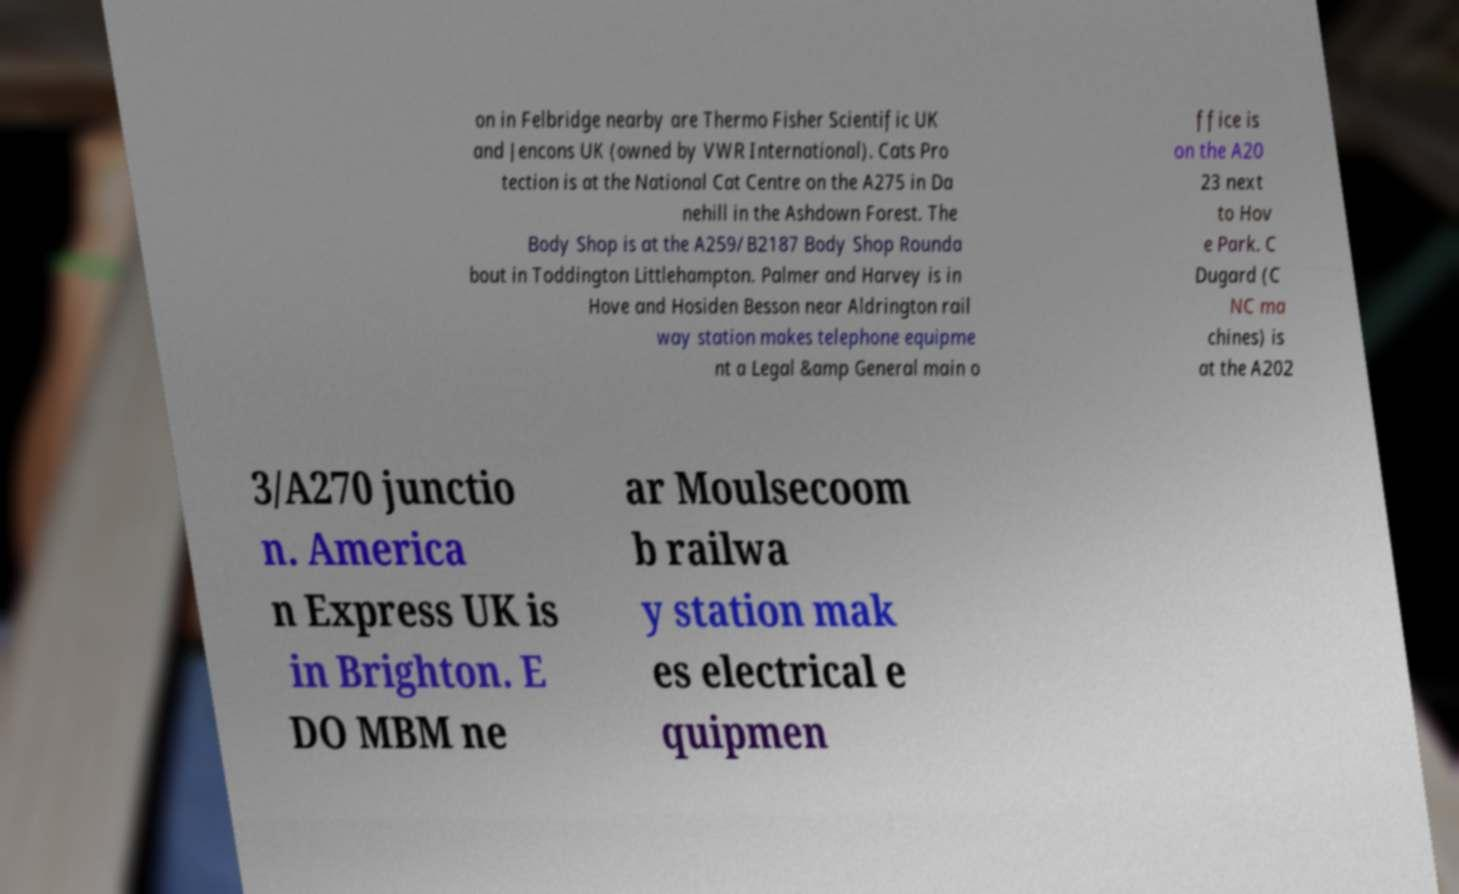Can you accurately transcribe the text from the provided image for me? on in Felbridge nearby are Thermo Fisher Scientific UK and Jencons UK (owned by VWR International). Cats Pro tection is at the National Cat Centre on the A275 in Da nehill in the Ashdown Forest. The Body Shop is at the A259/B2187 Body Shop Rounda bout in Toddington Littlehampton. Palmer and Harvey is in Hove and Hosiden Besson near Aldrington rail way station makes telephone equipme nt a Legal &amp General main o ffice is on the A20 23 next to Hov e Park. C Dugard (C NC ma chines) is at the A202 3/A270 junctio n. America n Express UK is in Brighton. E DO MBM ne ar Moulsecoom b railwa y station mak es electrical e quipmen 